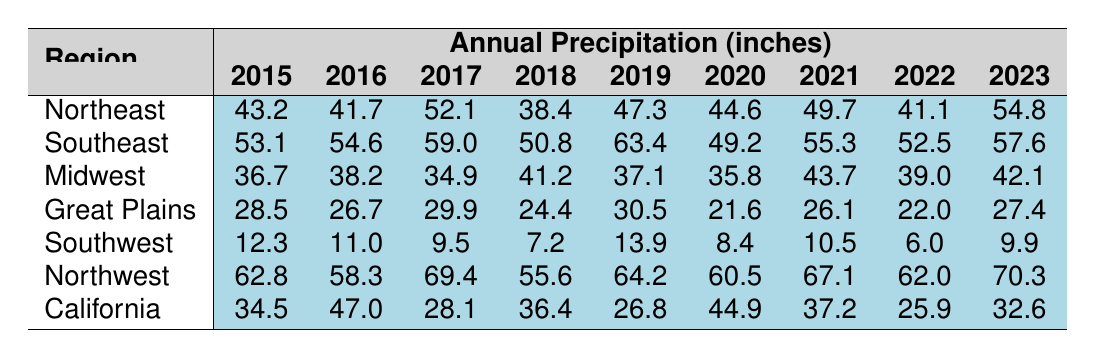What was the highest annual precipitation recorded in the Northeast region from 2015 to 2023? By inspecting the table, you can see that the highest annual precipitation in the Northeast region is 54.8 inches, which was recorded in 2023.
Answer: 54.8 inches Which region had the lowest annual precipitation in 2018? Referring to the table, the Southwest region had the lowest annual precipitation in 2018, with a total of 7.2 inches.
Answer: Southwest What is the average annual precipitation for the Midwest from 2015 to 2023? To find the average, sum the yearly precipitation values for the Midwest: 36.7 + 38.2 + 34.9 + 41.2 + 37.1 + 35.8 + 43.7 + 39.0 + 42.1 = 308.1 inches. There are 9 years, so the average is 308.1 / 9 = 34.5 inches.
Answer: 34.5 inches Did the precipitation in California increase from 2015 to 2023? By comparing the values in the table, California had 34.5 inches in 2015 and 32.6 inches in 2023, which shows a decrease.
Answer: No What was the difference in annual precipitation between the Southeast and the Great Plains in 2021? For 2021, the Southeast had 55.3 inches and the Great Plains had 26.1 inches. The difference is 55.3 - 26.1 = 29.2 inches.
Answer: 29.2 inches Which region experienced the highest recorded precipitation in 2019 and what was the amount? Looking at the table, the Southeast region had the highest recorded precipitation in 2019 with a total of 63.4 inches.
Answer: Southeast, 63.4 inches What trends can be observed in the annual precipitation for the Northwest region over the years? Analyzing the table shows a trend of increasing precipitation from 2015 (62.8 inches) to 2023 (70.3 inches), indicating a positive increase over the years.
Answer: Increasing trend What was the average of the annual precipitation totals for the Southwest region over the years provided? Summing the totals for the Southwest region gives us 12.3 + 11.0 + 9.5 + 7.2 + 13.9 + 8.4 + 10.5 + 6.0 + 9.9 = 88.7 inches. Dividing by 9 years results in an average of 88.7 / 9 ≈ 9.85 inches.
Answer: 9.85 inches How did the precipitation in the Northwest compare to California in 2022? In 2022, the Northwest had 62.0 inches and California had 25.9 inches. The comparison shows that the Northwest's precipitation was significantly higher than California's.
Answer: Yes, Northwest was higher Which region had the most consistent annual precipitation totals over the years, based on the smallest range between maximum and minimum? Reviewing the table shows that the Midwest had precipitation ranging from 34.9 to 43.7 inches (a range of 8.8 inches), which is smaller than any other region examined.
Answer: Midwest 